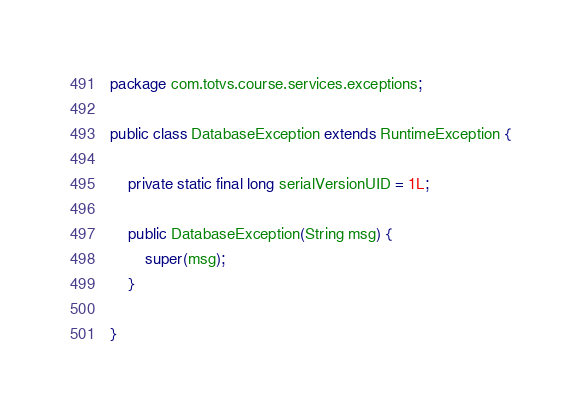Convert code to text. <code><loc_0><loc_0><loc_500><loc_500><_Java_>package com.totvs.course.services.exceptions;

public class DatabaseException extends RuntimeException {

	private static final long serialVersionUID = 1L;

	public DatabaseException(String msg) {
		super(msg);
	}

}
</code> 